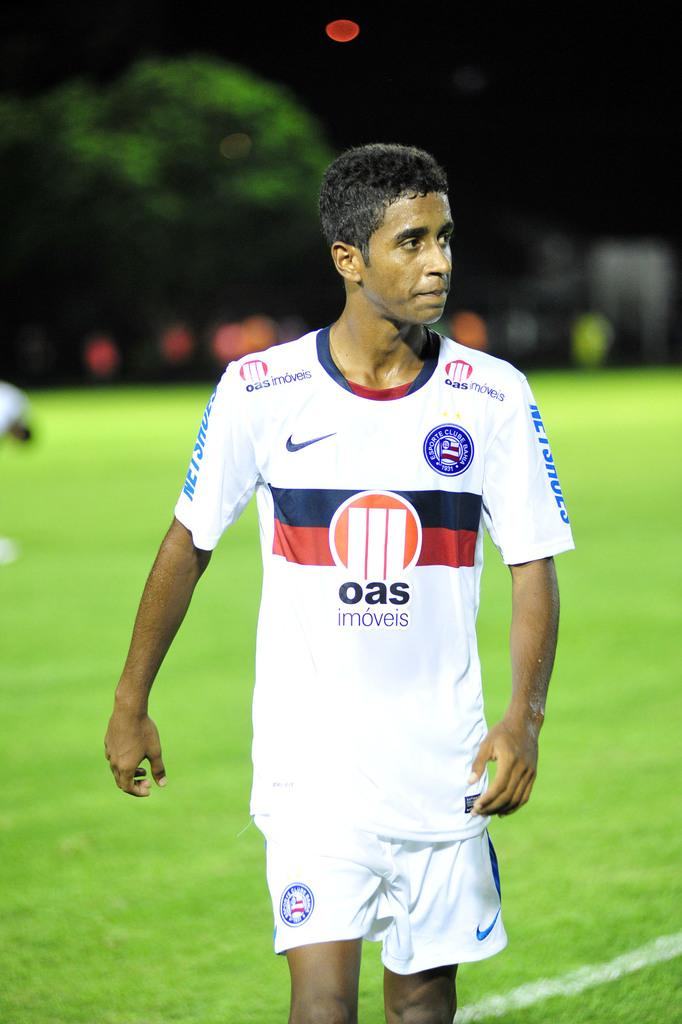<image>
Summarize the visual content of the image. a soccer player in a white jersey with OAS on the front 